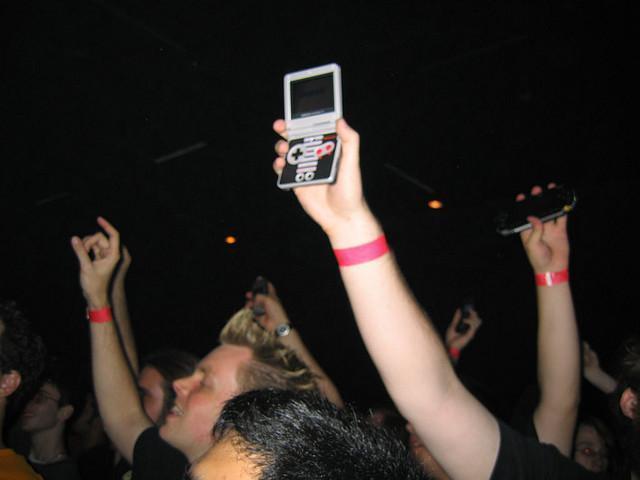The bottom portion of the screen that is furthest to the front looks like what video game controller?
Choose the right answer and clarify with the format: 'Answer: answer
Rationale: rationale.'
Options: Ps3, nes, ps4, n64. Answer: nes.
Rationale: The question doesn't make sense but the object visible that looks similar to another object looks like answer a. 